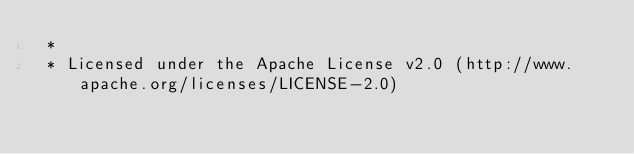Convert code to text. <code><loc_0><loc_0><loc_500><loc_500><_CSS_> *
 * Licensed under the Apache License v2.0 (http://www.apache.org/licenses/LICENSE-2.0)</code> 